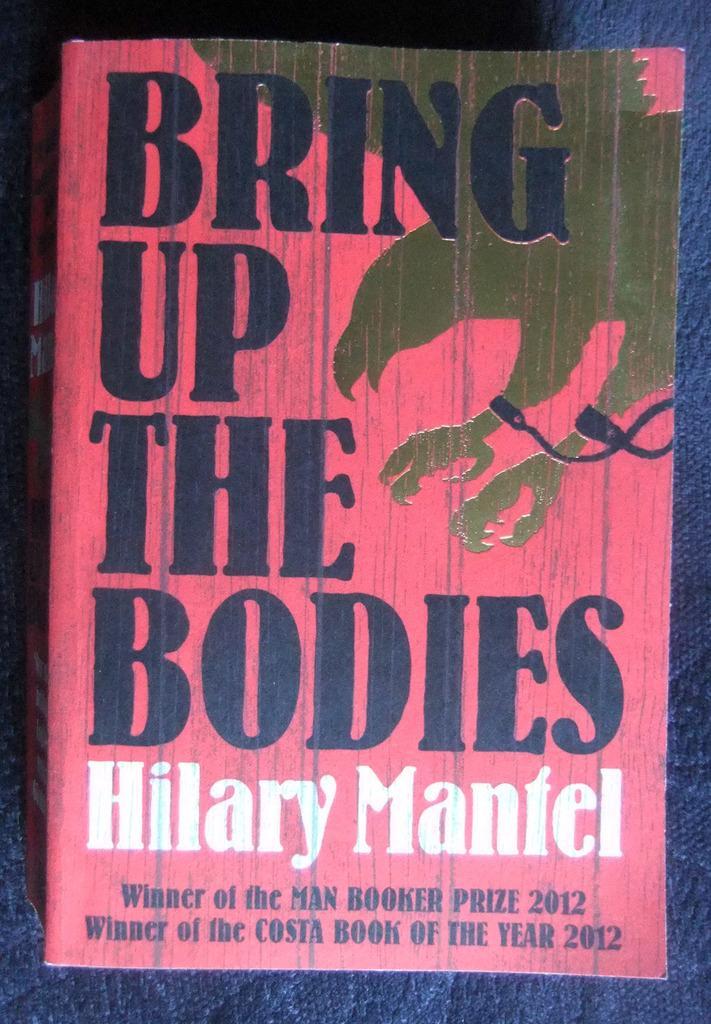Could you give a brief overview of what you see in this image? In this image we can see cover of a book on which it is written as bring up the bodies which is of pink color. 